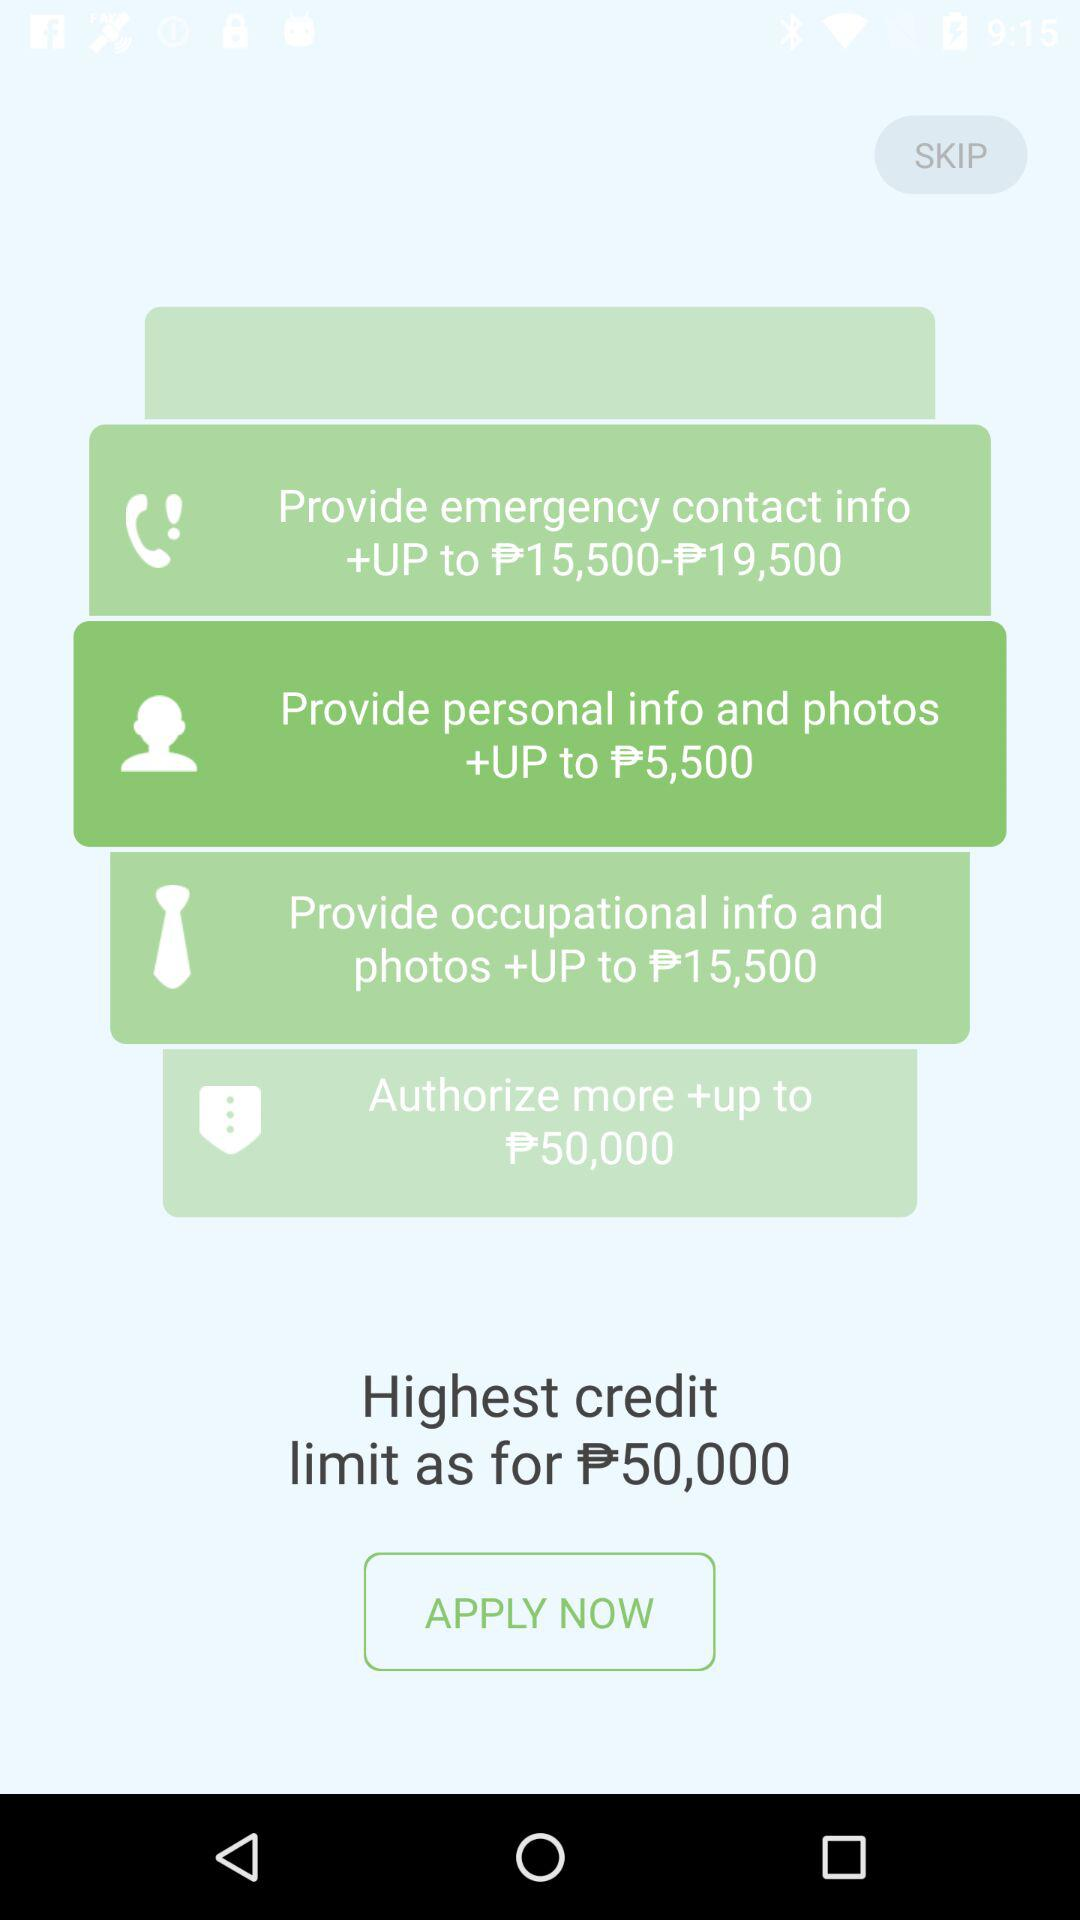How much is the highest credit limit?
Answer the question using a single word or phrase. 50,000 